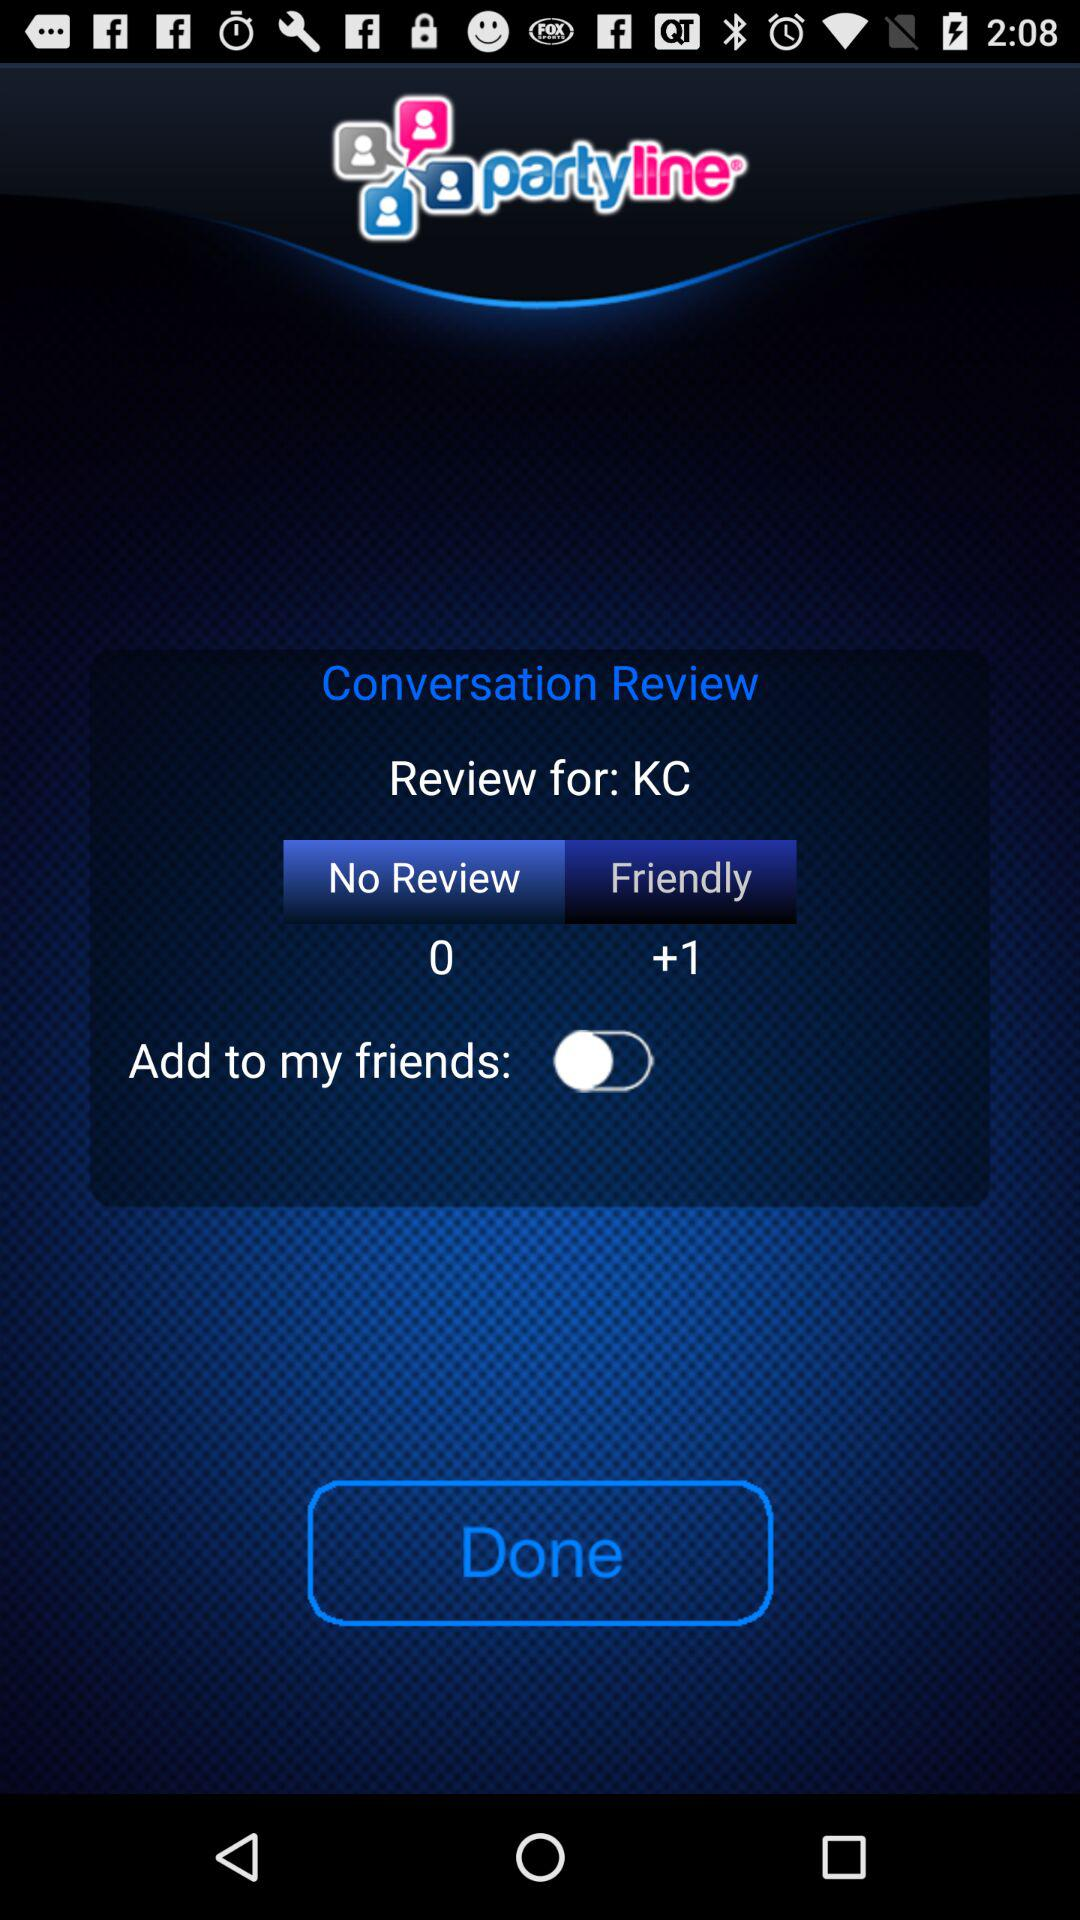How many more friendly reviews are there than no reviews?
Answer the question using a single word or phrase. 1 